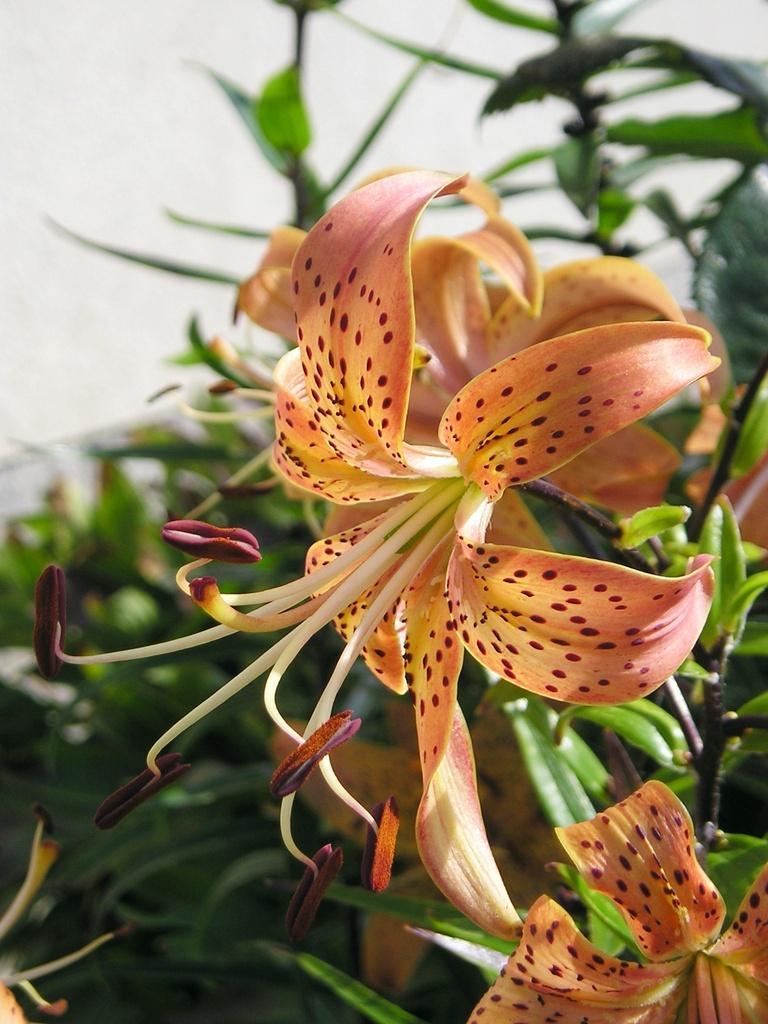What type of living organisms can be seen in the image? Plants can be seen in the image. What is unique about the plants in the image? There are tiny planets surrounding the plants. What can be seen in the background of the image? Clouds and the sky are visible in the background. What grade is the linen used for in the image? There is no linen present in the image, so it cannot be determined what grade it might be used for. 